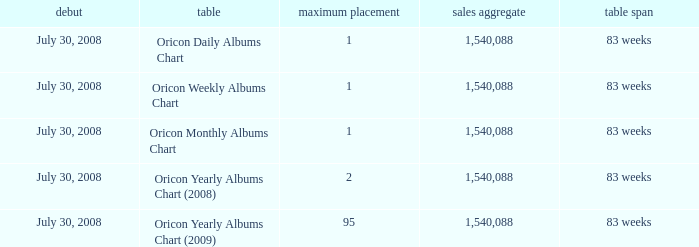How much Peak Position has Sales Total larger than 1,540,088? 0.0. 